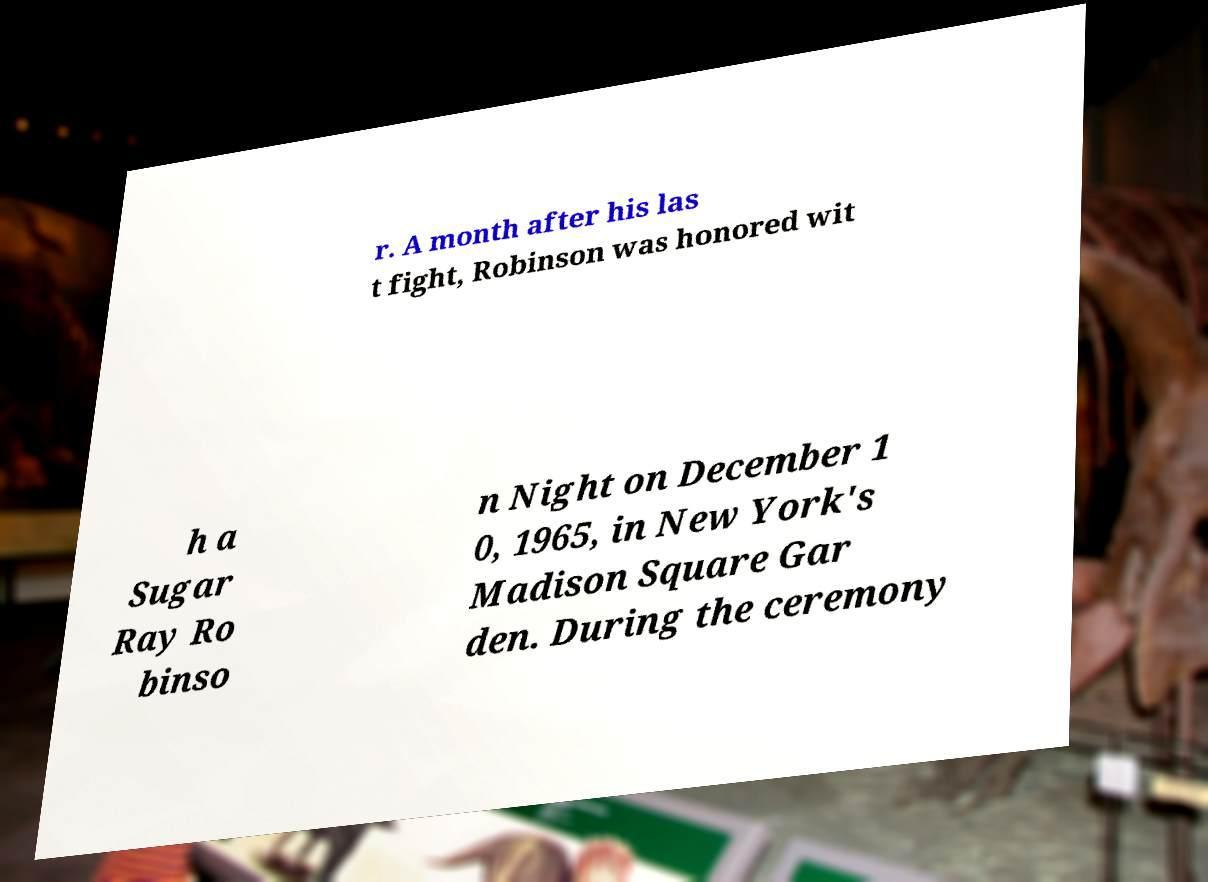Could you assist in decoding the text presented in this image and type it out clearly? r. A month after his las t fight, Robinson was honored wit h a Sugar Ray Ro binso n Night on December 1 0, 1965, in New York's Madison Square Gar den. During the ceremony 